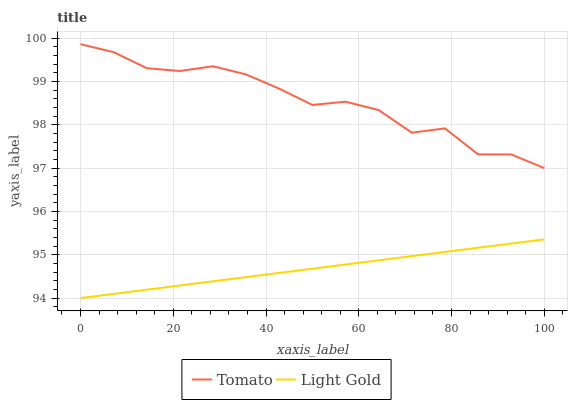Does Light Gold have the minimum area under the curve?
Answer yes or no. Yes. Does Tomato have the maximum area under the curve?
Answer yes or no. Yes. Does Light Gold have the maximum area under the curve?
Answer yes or no. No. Is Light Gold the smoothest?
Answer yes or no. Yes. Is Tomato the roughest?
Answer yes or no. Yes. Is Light Gold the roughest?
Answer yes or no. No. Does Tomato have the highest value?
Answer yes or no. Yes. Does Light Gold have the highest value?
Answer yes or no. No. Is Light Gold less than Tomato?
Answer yes or no. Yes. Is Tomato greater than Light Gold?
Answer yes or no. Yes. Does Light Gold intersect Tomato?
Answer yes or no. No. 